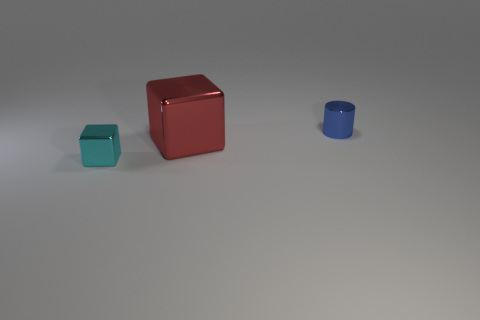Add 1 large red objects. How many objects exist? 4 Subtract all cyan blocks. How many blocks are left? 1 Subtract 0 cyan spheres. How many objects are left? 3 Subtract all cubes. How many objects are left? 1 Subtract 1 cylinders. How many cylinders are left? 0 Subtract all yellow cylinders. Subtract all purple blocks. How many cylinders are left? 1 Subtract all cyan spheres. How many cyan cylinders are left? 0 Subtract all big cyan matte objects. Subtract all large cubes. How many objects are left? 2 Add 1 tiny metallic things. How many tiny metallic things are left? 3 Add 2 tiny green metal objects. How many tiny green metal objects exist? 2 